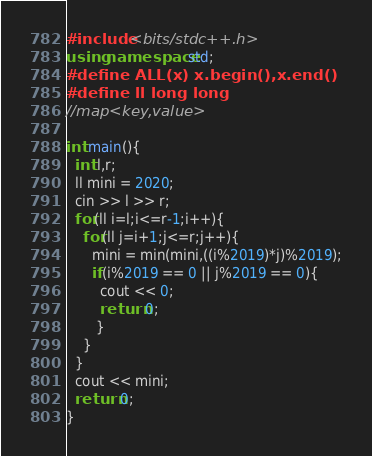<code> <loc_0><loc_0><loc_500><loc_500><_C++_>#include <bits/stdc++.h>
using namespace std;
#define ALL(x) x.begin(),x.end()
#define ll long long
//map<key,value>

int main(){
  int l,r;
  ll mini = 2020;
  cin >> l >> r;
  for(ll i=l;i<=r-1;i++){
    for(ll j=i+1;j<=r;j++){
      mini = min(mini,((i%2019)*j)%2019);
      if(i%2019 == 0 || j%2019 == 0){
        cout << 0;
        return 0;
       }
    }
  }
  cout << mini;
  return 0;
}
</code> 